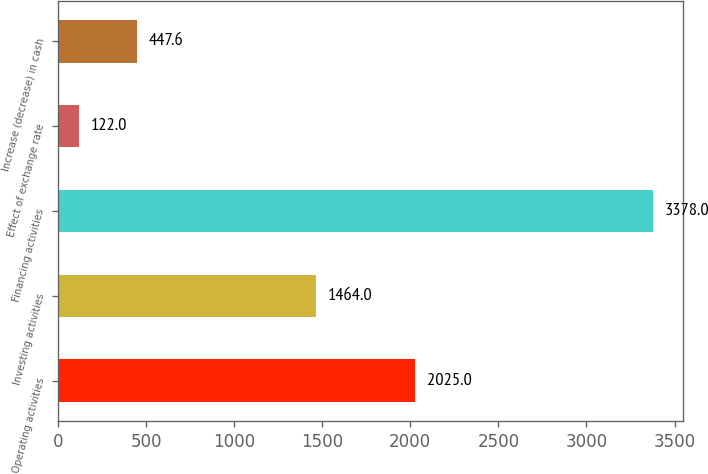Convert chart to OTSL. <chart><loc_0><loc_0><loc_500><loc_500><bar_chart><fcel>Operating activities<fcel>Investing activities<fcel>Financing activities<fcel>Effect of exchange rate<fcel>Increase (decrease) in cash<nl><fcel>2025<fcel>1464<fcel>3378<fcel>122<fcel>447.6<nl></chart> 